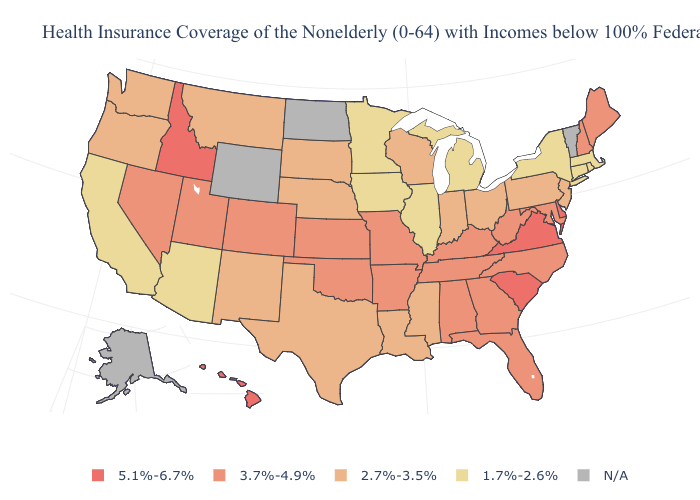What is the highest value in the USA?
Give a very brief answer. 5.1%-6.7%. Name the states that have a value in the range 5.1%-6.7%?
Be succinct. Delaware, Hawaii, Idaho, South Carolina, Virginia. What is the highest value in the West ?
Write a very short answer. 5.1%-6.7%. Which states have the lowest value in the USA?
Quick response, please. Arizona, California, Connecticut, Illinois, Iowa, Massachusetts, Michigan, Minnesota, New York, Rhode Island. Name the states that have a value in the range 3.7%-4.9%?
Short answer required. Alabama, Arkansas, Colorado, Florida, Georgia, Kansas, Kentucky, Maine, Maryland, Missouri, Nevada, New Hampshire, North Carolina, Oklahoma, Tennessee, Utah, West Virginia. What is the value of North Dakota?
Give a very brief answer. N/A. What is the lowest value in the MidWest?
Give a very brief answer. 1.7%-2.6%. Name the states that have a value in the range 2.7%-3.5%?
Concise answer only. Indiana, Louisiana, Mississippi, Montana, Nebraska, New Jersey, New Mexico, Ohio, Oregon, Pennsylvania, South Dakota, Texas, Washington, Wisconsin. Name the states that have a value in the range N/A?
Answer briefly. Alaska, North Dakota, Vermont, Wyoming. Among the states that border Texas , does Arkansas have the lowest value?
Write a very short answer. No. What is the lowest value in the USA?
Answer briefly. 1.7%-2.6%. Name the states that have a value in the range N/A?
Write a very short answer. Alaska, North Dakota, Vermont, Wyoming. Is the legend a continuous bar?
Keep it brief. No. 